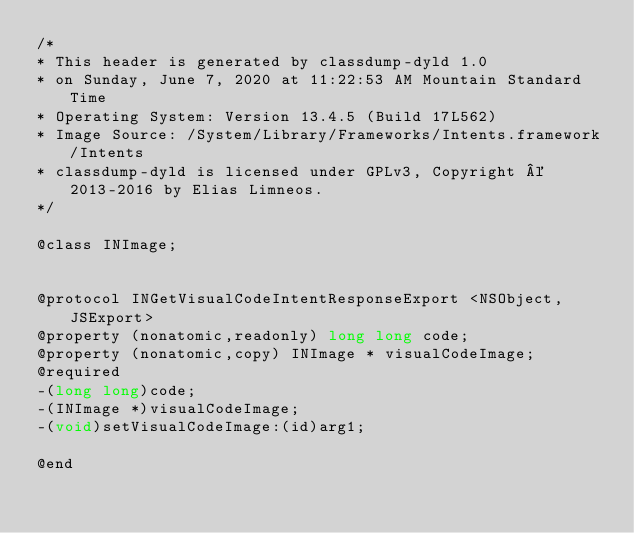Convert code to text. <code><loc_0><loc_0><loc_500><loc_500><_C_>/*
* This header is generated by classdump-dyld 1.0
* on Sunday, June 7, 2020 at 11:22:53 AM Mountain Standard Time
* Operating System: Version 13.4.5 (Build 17L562)
* Image Source: /System/Library/Frameworks/Intents.framework/Intents
* classdump-dyld is licensed under GPLv3, Copyright © 2013-2016 by Elias Limneos.
*/

@class INImage;


@protocol INGetVisualCodeIntentResponseExport <NSObject,JSExport>
@property (nonatomic,readonly) long long code; 
@property (nonatomic,copy) INImage * visualCodeImage; 
@required
-(long long)code;
-(INImage *)visualCodeImage;
-(void)setVisualCodeImage:(id)arg1;

@end

</code> 